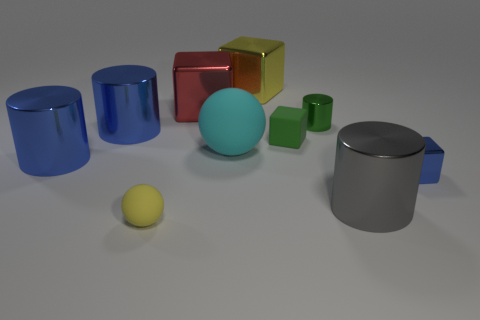Subtract all cyan spheres. How many spheres are left? 1 Subtract all tiny blue blocks. How many blocks are left? 3 Add 3 tiny yellow rubber balls. How many tiny yellow rubber balls exist? 4 Subtract 1 green blocks. How many objects are left? 9 Subtract all balls. How many objects are left? 8 Subtract 2 balls. How many balls are left? 0 Subtract all cyan spheres. Subtract all cyan cubes. How many spheres are left? 1 Subtract all green cylinders. How many cyan blocks are left? 0 Subtract all big red things. Subtract all green things. How many objects are left? 7 Add 2 big cyan matte objects. How many big cyan matte objects are left? 3 